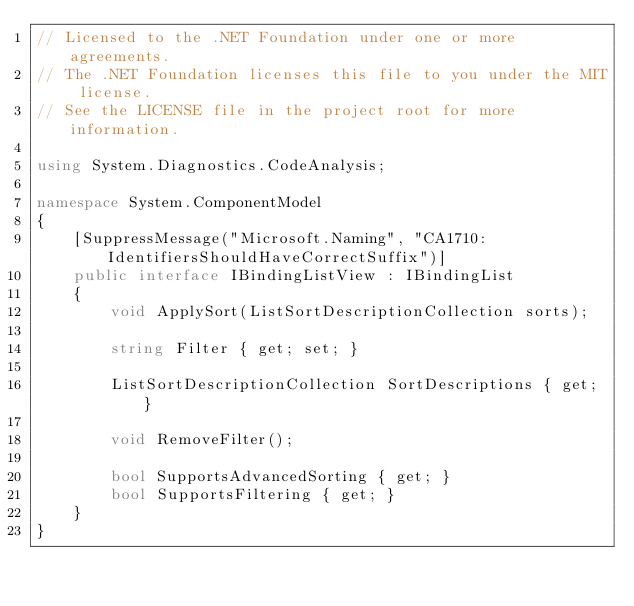<code> <loc_0><loc_0><loc_500><loc_500><_C#_>// Licensed to the .NET Foundation under one or more agreements.
// The .NET Foundation licenses this file to you under the MIT license.
// See the LICENSE file in the project root for more information.

using System.Diagnostics.CodeAnalysis;

namespace System.ComponentModel
{
    [SuppressMessage("Microsoft.Naming", "CA1710:IdentifiersShouldHaveCorrectSuffix")]
    public interface IBindingListView : IBindingList
    {
        void ApplySort(ListSortDescriptionCollection sorts);

        string Filter { get; set; }

        ListSortDescriptionCollection SortDescriptions { get; }

        void RemoveFilter();

        bool SupportsAdvancedSorting { get; }
        bool SupportsFiltering { get; }
    }
}
</code> 